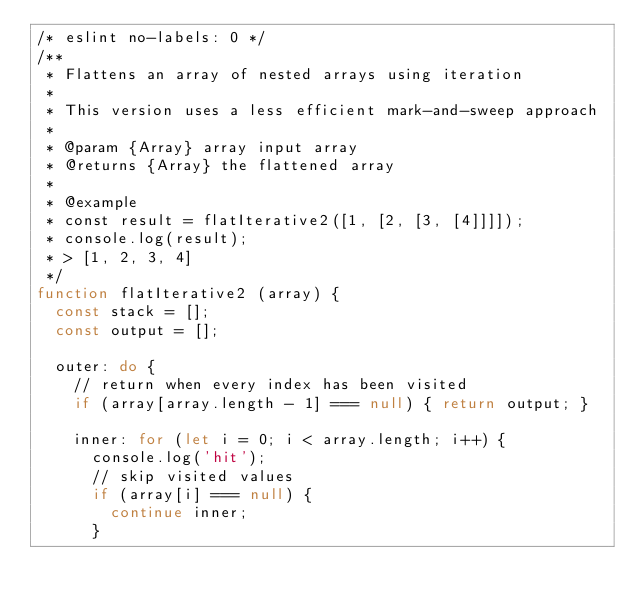Convert code to text. <code><loc_0><loc_0><loc_500><loc_500><_JavaScript_>/* eslint no-labels: 0 */
/**
 * Flattens an array of nested arrays using iteration
 *
 * This version uses a less efficient mark-and-sweep approach
 *
 * @param {Array} array input array
 * @returns {Array} the flattened array
 *
 * @example
 * const result = flatIterative2([1, [2, [3, [4]]]]);
 * console.log(result);
 * > [1, 2, 3, 4]
 */
function flatIterative2 (array) {
  const stack = [];
  const output = [];

  outer: do {
    // return when every index has been visited
    if (array[array.length - 1] === null) { return output; }

    inner: for (let i = 0; i < array.length; i++) {
      console.log('hit');
      // skip visited values
      if (array[i] === null) {
        continue inner;
      }</code> 